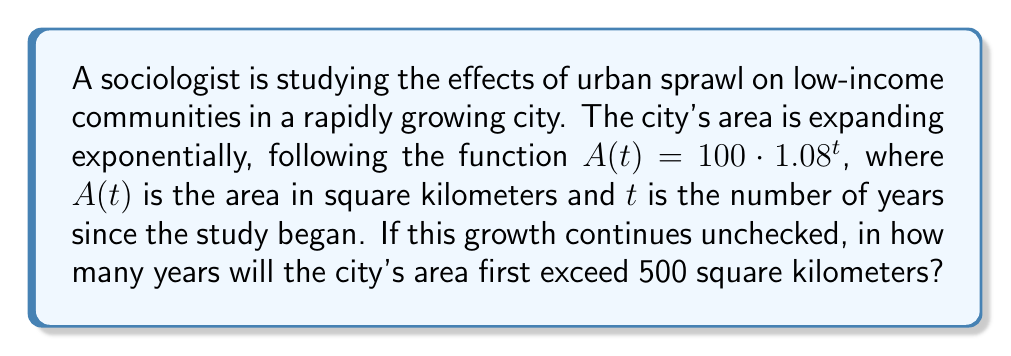Can you solve this math problem? To solve this problem, we need to use the exponential function given and solve for $t$ when $A(t)$ exceeds 500 sq km.

1) We start with the equation: $A(t) = 100 \cdot 1.08^t$

2) We want to find $t$ when $A(t) > 500$, so we set up the inequality:
   $100 \cdot 1.08^t > 500$

3) Divide both sides by 100:
   $1.08^t > 5$

4) Take the natural logarithm of both sides:
   $\ln(1.08^t) > \ln(5)$

5) Using the logarithm property $\ln(a^b) = b\ln(a)$:
   $t \cdot \ln(1.08) > \ln(5)$

6) Divide both sides by $\ln(1.08)$:
   $t > \frac{\ln(5)}{\ln(1.08)} \approx 20.82$

7) Since we're looking for the first year the area exceeds 500 sq km, and $t$ represents whole years, we need to round up to the next integer.
Answer: The city's area will first exceed 500 square kilometers in 21 years. 